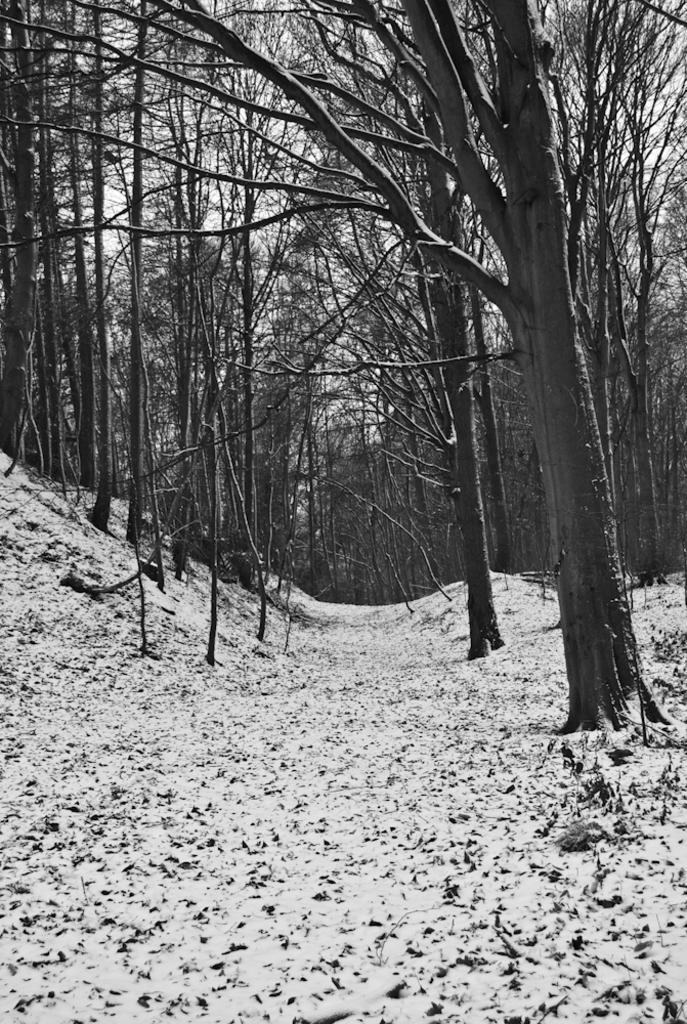Can you describe this image briefly? In the given image, I can see numerous trees and this place looks like ice land and ground is full filled with ice, snow and here between the trees we can also see the route. 